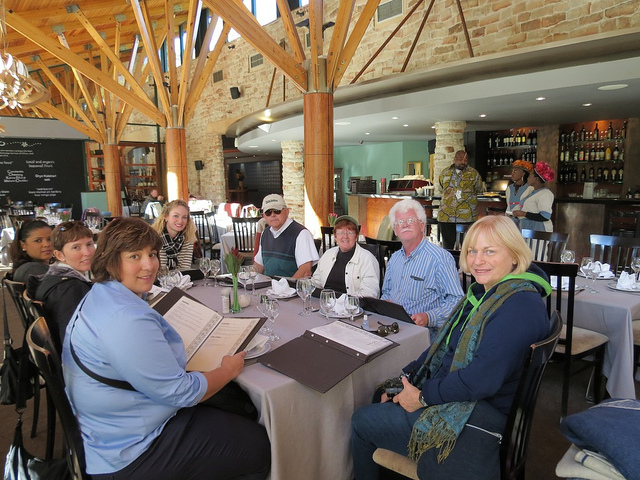How many dining tables are in the photo? 2 